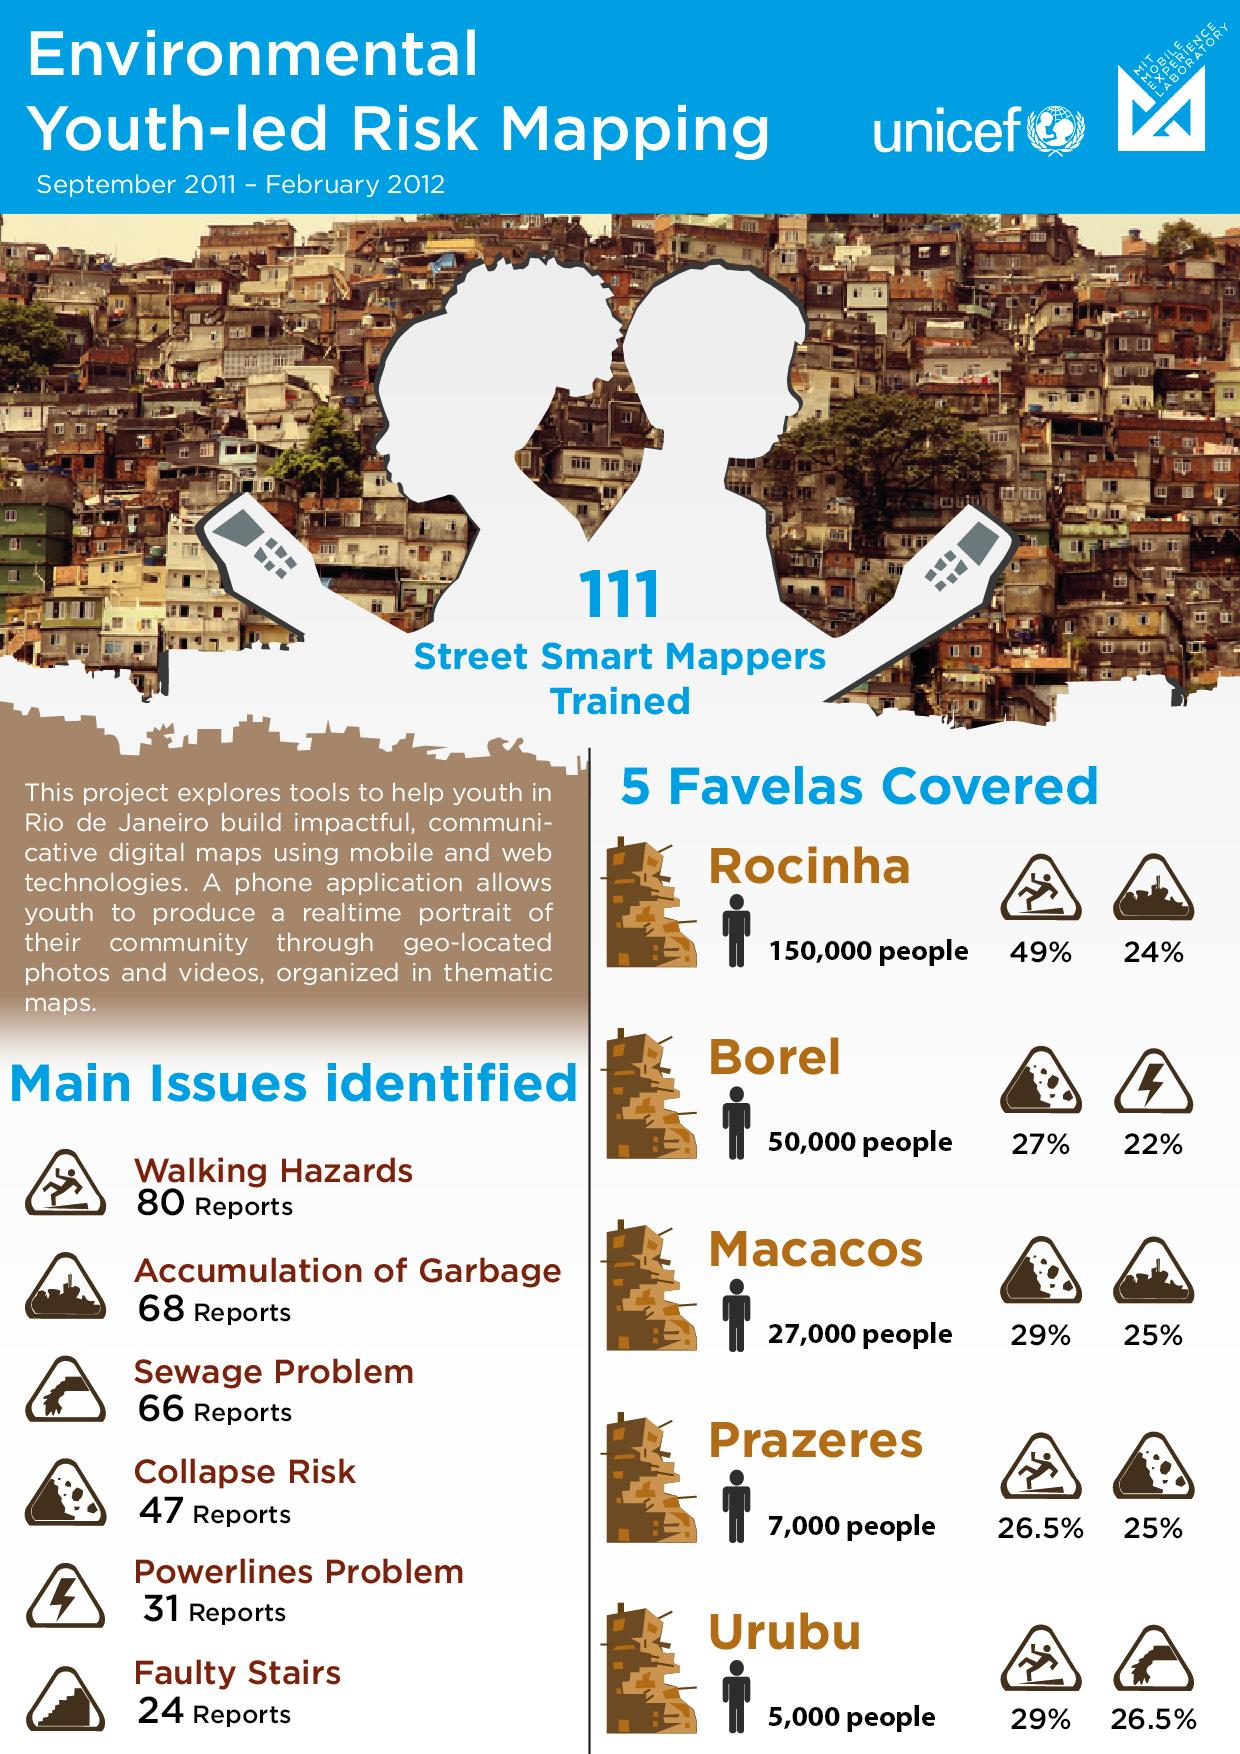Highlight a few significant elements in this photo. Rocinha, Prazeres, and Urubu favelas have walking hazards. In Prazeres, approximately 26.5% of reports received are related to walking hazards. According to the information provided, 22% of Borel had a problem with powerlines. The region or favela of Prazeres had a 25% risk of collapse. The sign of a person falling indicates the presence of walking hazards. 